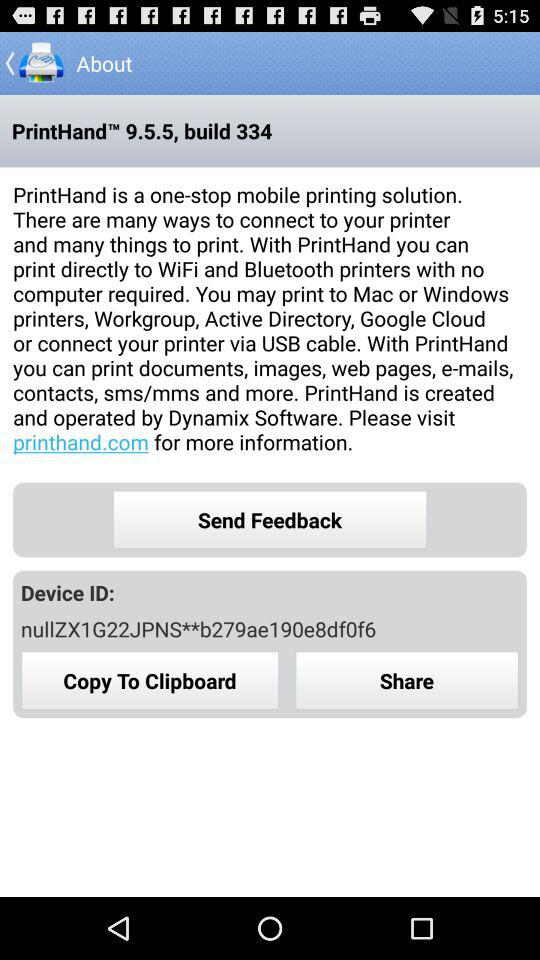What website can we visit for more information? The website that you can visit is printhand.com. 